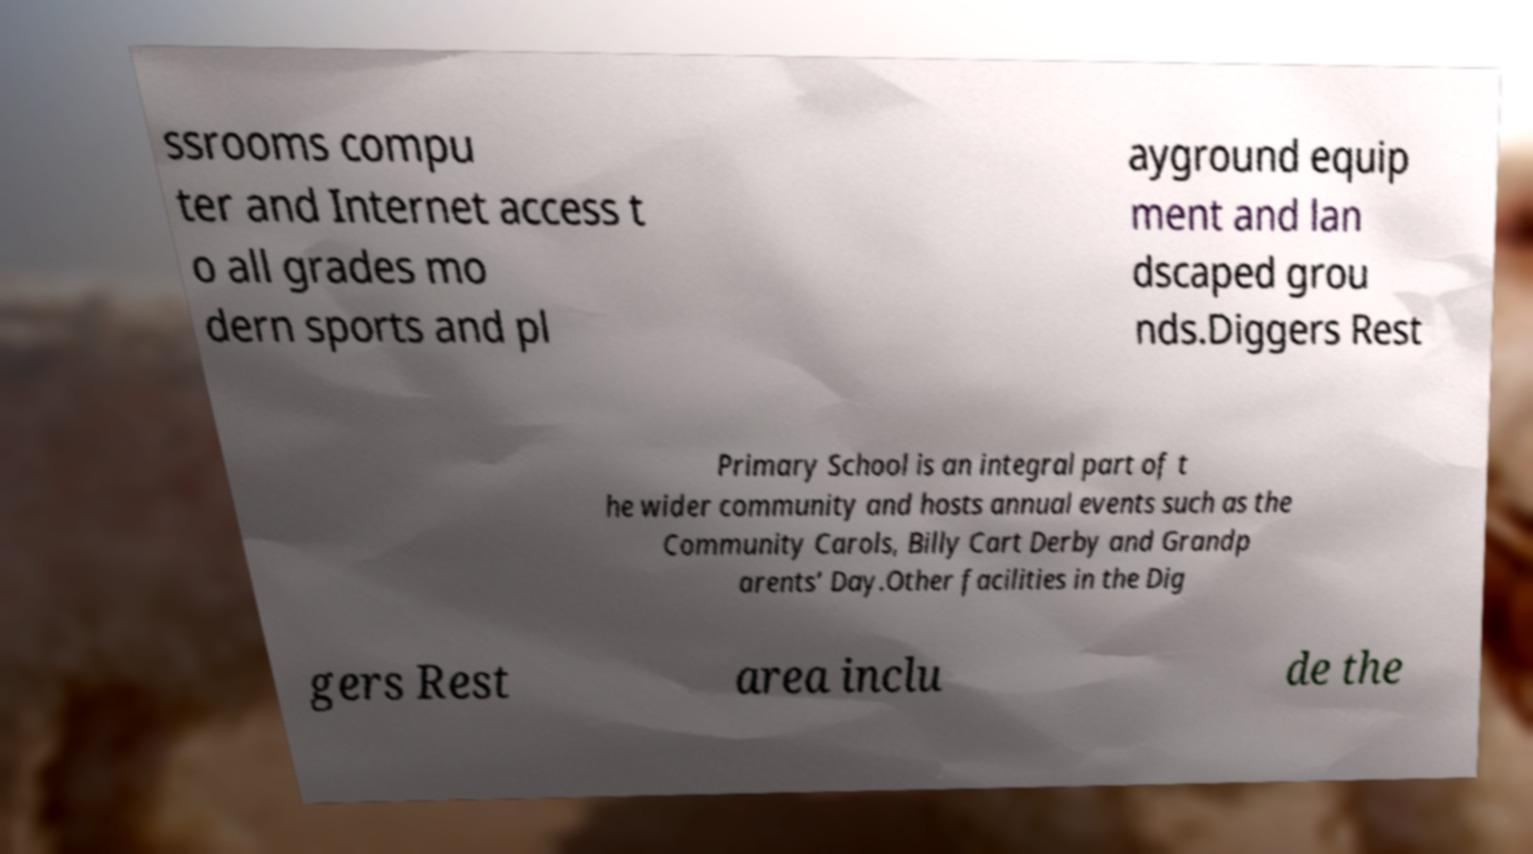Could you extract and type out the text from this image? ssrooms compu ter and Internet access t o all grades mo dern sports and pl ayground equip ment and lan dscaped grou nds.Diggers Rest Primary School is an integral part of t he wider community and hosts annual events such as the Community Carols, Billy Cart Derby and Grandp arents’ Day.Other facilities in the Dig gers Rest area inclu de the 